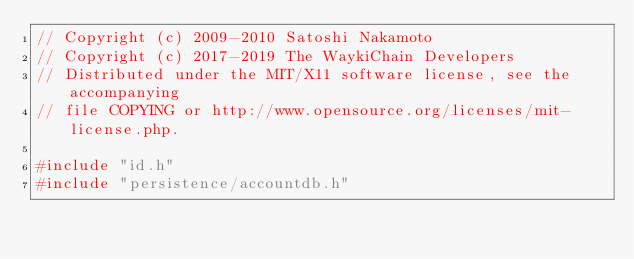<code> <loc_0><loc_0><loc_500><loc_500><_C++_>// Copyright (c) 2009-2010 Satoshi Nakamoto
// Copyright (c) 2017-2019 The WaykiChain Developers
// Distributed under the MIT/X11 software license, see the accompanying
// file COPYING or http://www.opensource.org/licenses/mit-license.php.

#include "id.h"
#include "persistence/accountdb.h"</code> 